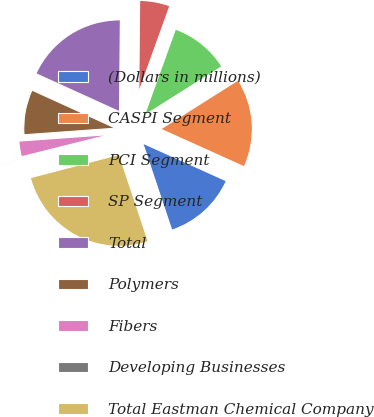Convert chart. <chart><loc_0><loc_0><loc_500><loc_500><pie_chart><fcel>(Dollars in millions)<fcel>CASPI Segment<fcel>PCI Segment<fcel>SP Segment<fcel>Total<fcel>Polymers<fcel>Fibers<fcel>Developing Businesses<fcel>Total Eastman Chemical Company<nl><fcel>13.12%<fcel>15.71%<fcel>10.53%<fcel>5.35%<fcel>18.35%<fcel>7.94%<fcel>2.76%<fcel>0.17%<fcel>26.06%<nl></chart> 